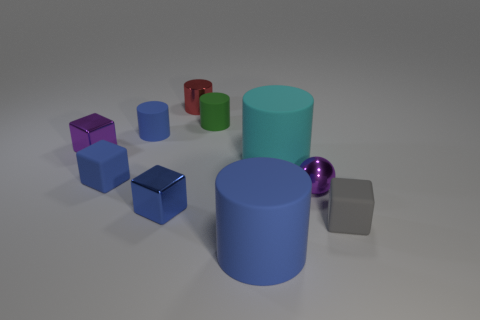Subtract all red shiny cylinders. How many cylinders are left? 4 Subtract all purple cubes. How many cubes are left? 3 Subtract 4 cylinders. How many cylinders are left? 1 Subtract all balls. How many objects are left? 9 Subtract all brown cubes. How many cyan cylinders are left? 1 Subtract 0 red blocks. How many objects are left? 10 Subtract all gray spheres. Subtract all green blocks. How many spheres are left? 1 Subtract all tiny shiny spheres. Subtract all matte cubes. How many objects are left? 7 Add 6 metal cylinders. How many metal cylinders are left? 7 Add 7 red objects. How many red objects exist? 8 